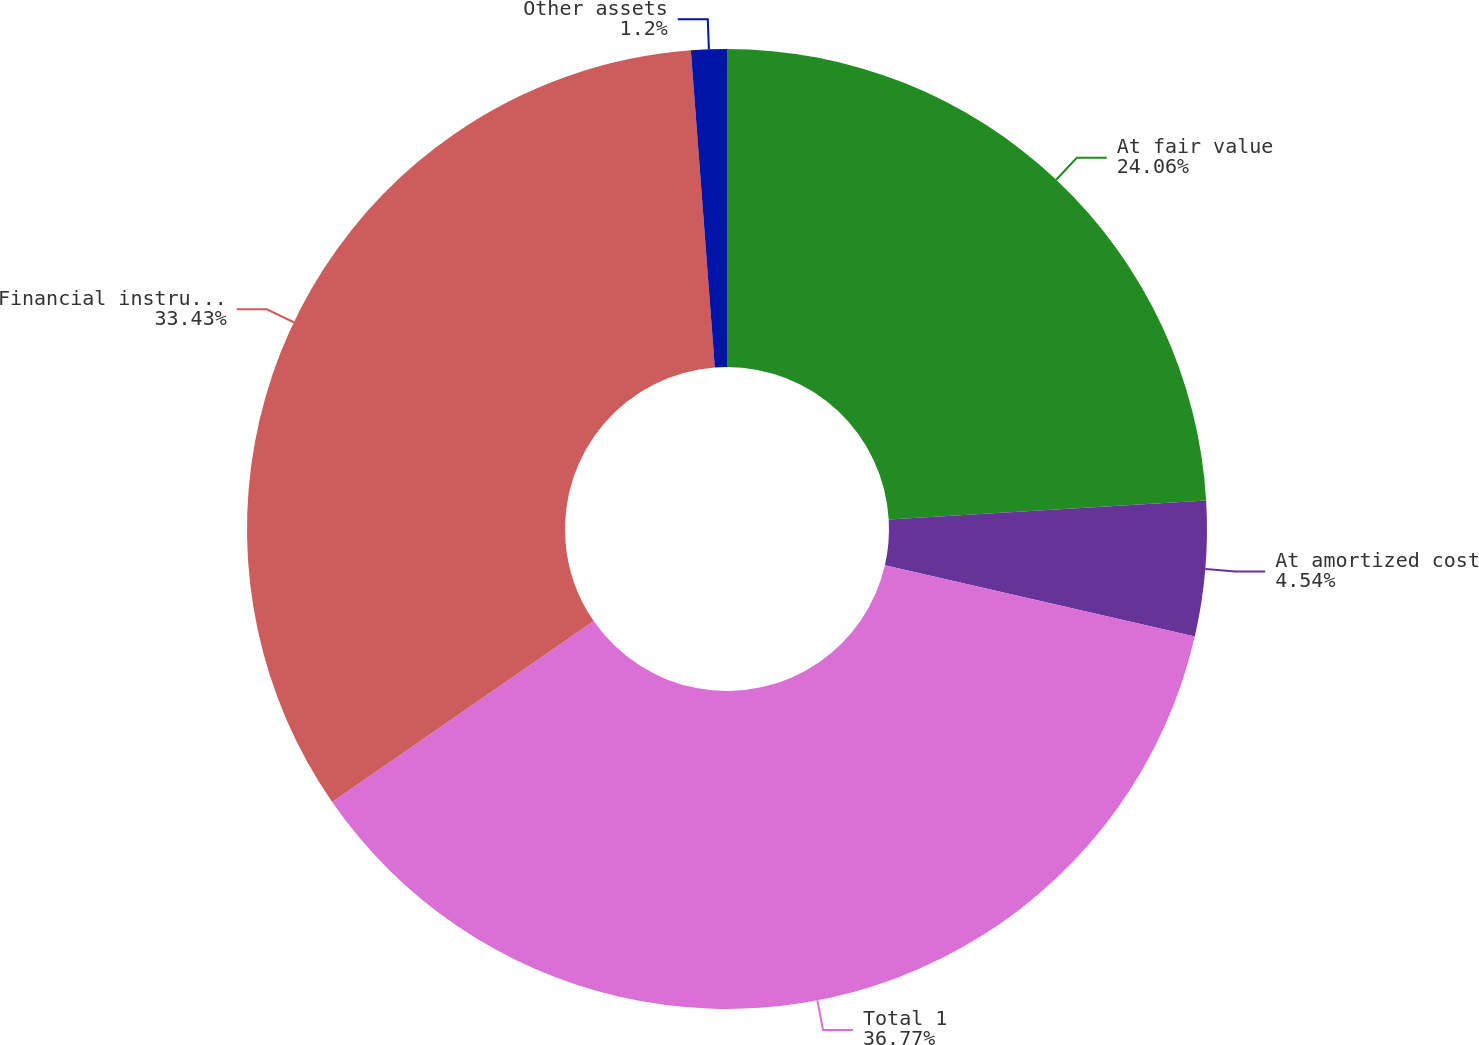Convert chart to OTSL. <chart><loc_0><loc_0><loc_500><loc_500><pie_chart><fcel>At fair value<fcel>At amortized cost<fcel>Total 1<fcel>Financial instruments 2<fcel>Other assets<nl><fcel>24.06%<fcel>4.54%<fcel>36.78%<fcel>33.43%<fcel>1.2%<nl></chart> 